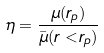Convert formula to latex. <formula><loc_0><loc_0><loc_500><loc_500>\eta = \frac { \mu ( r _ { p } ) } { \bar { \mu } ( r < r _ { p } ) }</formula> 